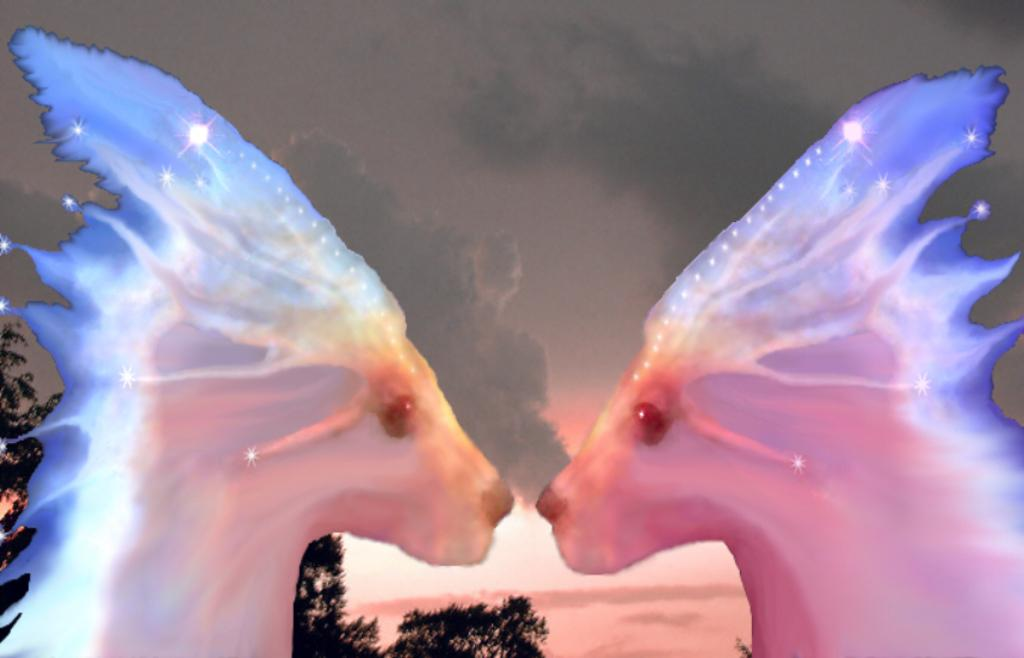What type of editing has been done to the image? The image is edited, but the specific type of editing is not mentioned in the facts. What types of animals can be seen in the image? There are animals in the image, but the specific types of animals are not mentioned in the facts. What can be seen in the background of the image? There are trees visible in the background of the image. What is visible in the sky in the image? The sky is visible in the image, and it appears cloudy. What is the stage like in the image? There is no stage present in the image. What type of fear do the animals in the image exhibit? There is no fear exhibited by the animals in the image, as their emotional state is not mentioned in the facts. 